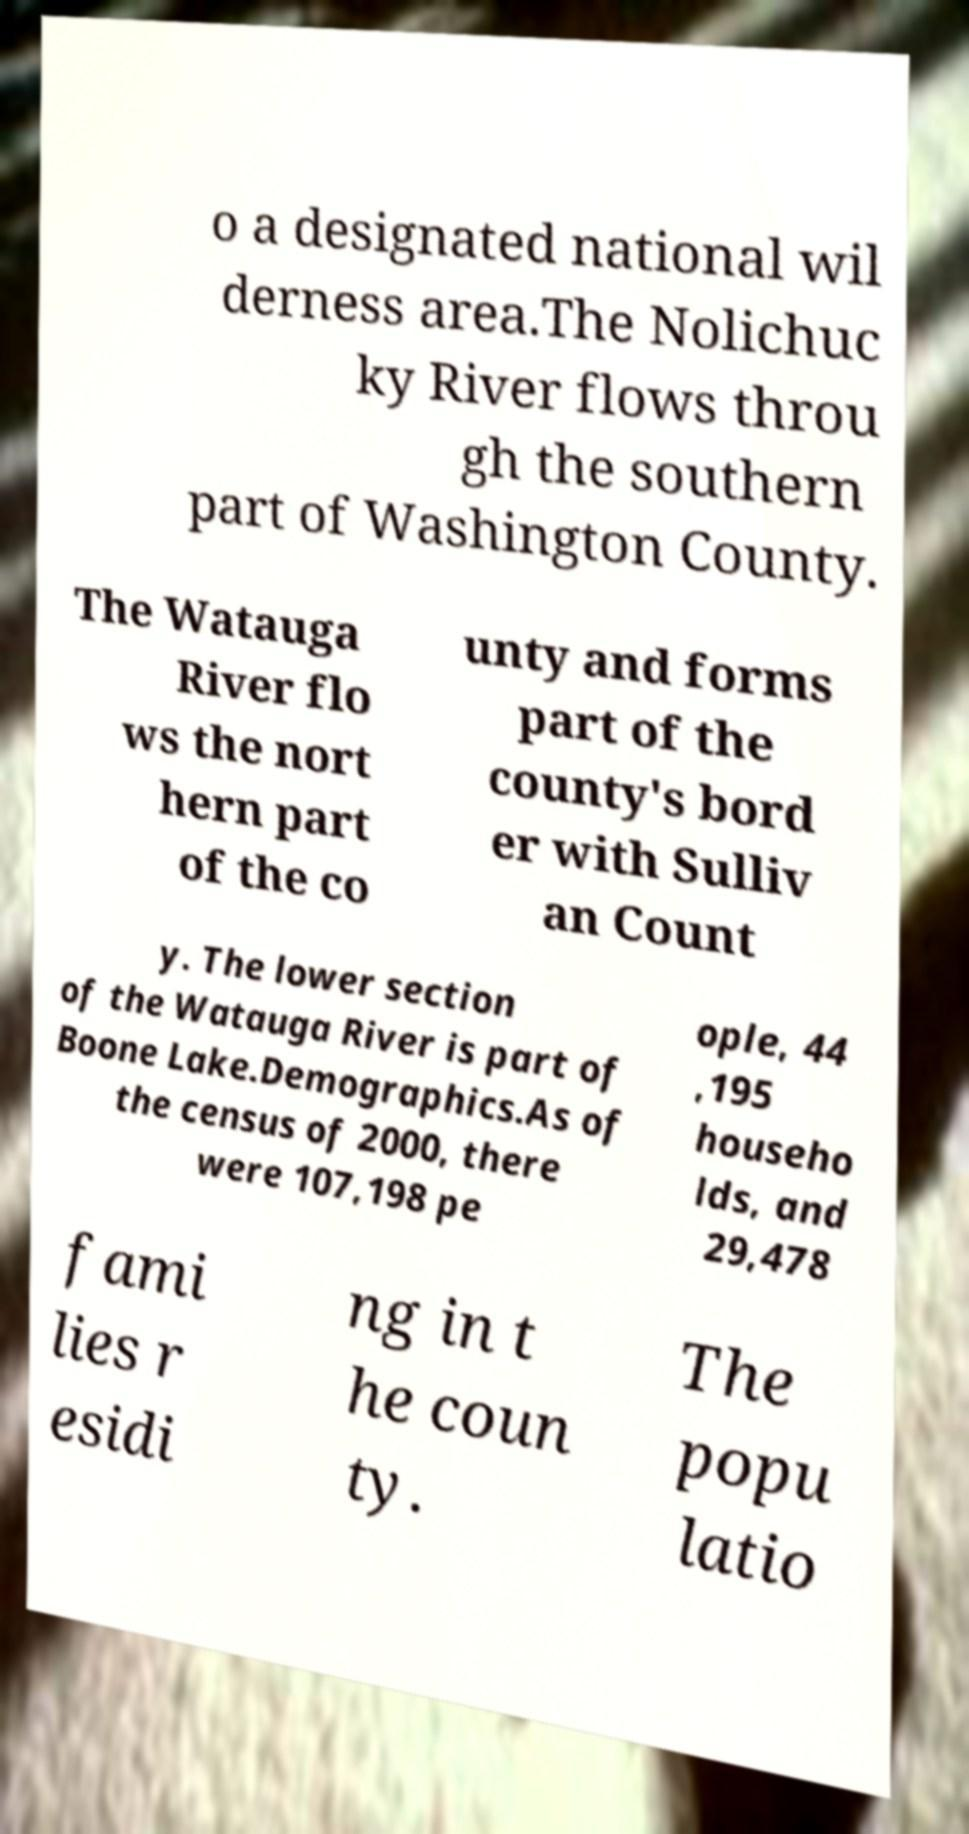Could you assist in decoding the text presented in this image and type it out clearly? o a designated national wil derness area.The Nolichuc ky River flows throu gh the southern part of Washington County. The Watauga River flo ws the nort hern part of the co unty and forms part of the county's bord er with Sulliv an Count y. The lower section of the Watauga River is part of Boone Lake.Demographics.As of the census of 2000, there were 107,198 pe ople, 44 ,195 househo lds, and 29,478 fami lies r esidi ng in t he coun ty. The popu latio 